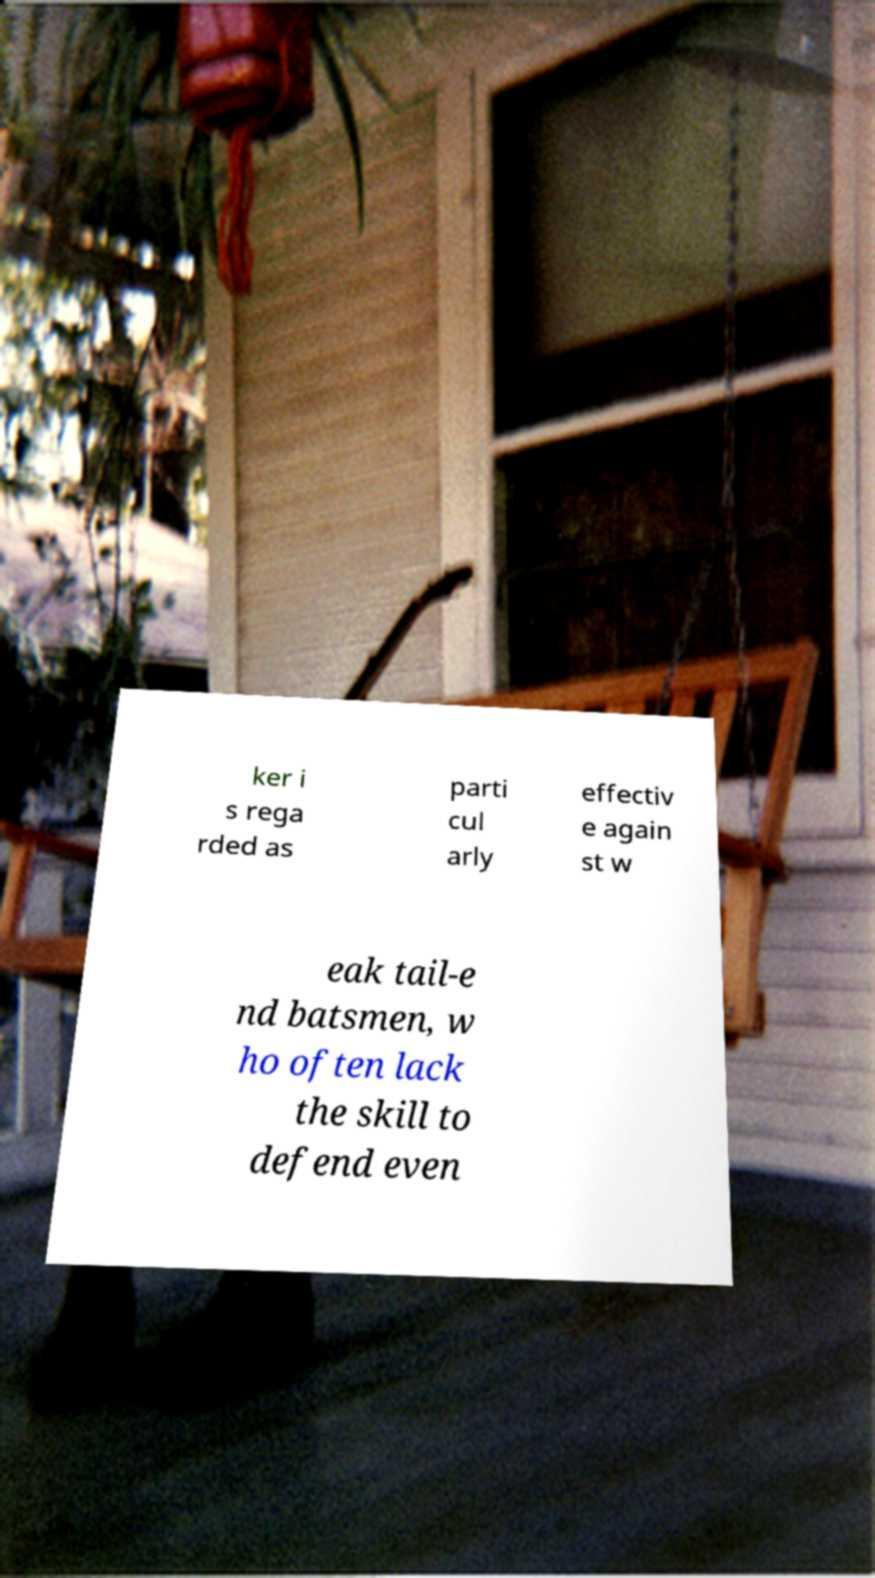There's text embedded in this image that I need extracted. Can you transcribe it verbatim? ker i s rega rded as parti cul arly effectiv e again st w eak tail-e nd batsmen, w ho often lack the skill to defend even 